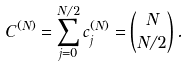Convert formula to latex. <formula><loc_0><loc_0><loc_500><loc_500>C ^ { ( N ) } = \sum _ { j = 0 } ^ { N / 2 } c ^ { ( N ) } _ { j } = \binom { N } { N / 2 } \, .</formula> 